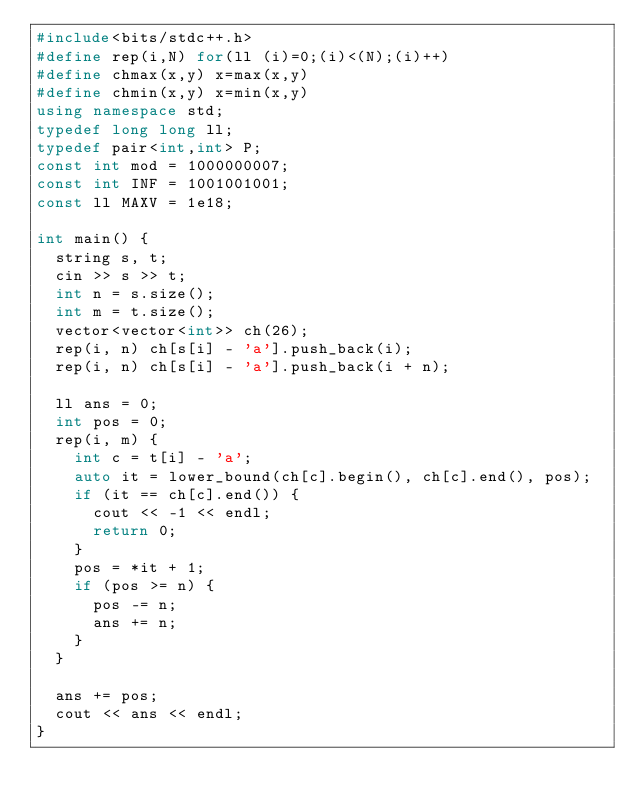<code> <loc_0><loc_0><loc_500><loc_500><_C++_>#include<bits/stdc++.h>
#define rep(i,N) for(ll (i)=0;(i)<(N);(i)++)
#define chmax(x,y) x=max(x,y)
#define chmin(x,y) x=min(x,y)
using namespace std;
typedef long long ll;
typedef pair<int,int> P;
const int mod = 1000000007;
const int INF = 1001001001;
const ll MAXV = 1e18;

int main() {
  string s, t;
  cin >> s >> t;
  int n = s.size();
  int m = t.size();
  vector<vector<int>> ch(26);
  rep(i, n) ch[s[i] - 'a'].push_back(i);
  rep(i, n) ch[s[i] - 'a'].push_back(i + n);

  ll ans = 0;
  int pos = 0;
  rep(i, m) {
    int c = t[i] - 'a';
    auto it = lower_bound(ch[c].begin(), ch[c].end(), pos);
    if (it == ch[c].end()) {
      cout << -1 << endl;
      return 0;
    }
    pos = *it + 1;
    if (pos >= n) {
      pos -= n;
      ans += n;
    }
  }

  ans += pos;
  cout << ans << endl;
}</code> 